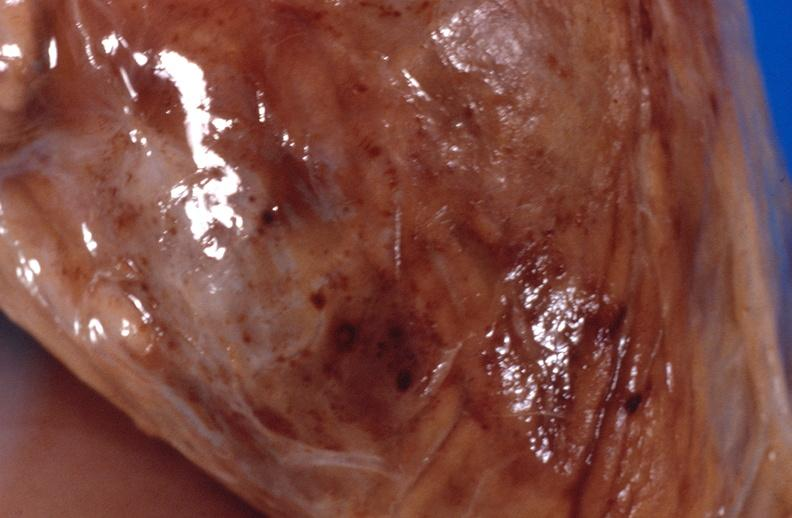s muscle present?
Answer the question using a single word or phrase. Yes 